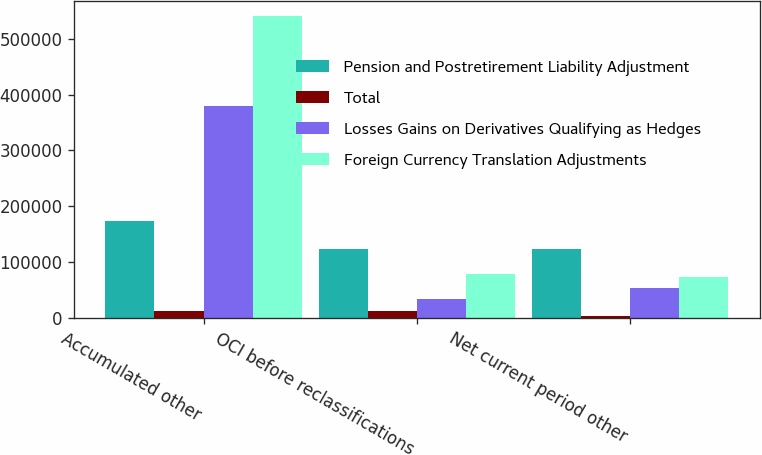<chart> <loc_0><loc_0><loc_500><loc_500><stacked_bar_chart><ecel><fcel>Accumulated other<fcel>OCI before reclassifications<fcel>Net current period other<nl><fcel>Pension and Postretirement Liability Adjustment<fcel>173342<fcel>124157<fcel>124157<nl><fcel>Total<fcel>12371<fcel>13006<fcel>2970<nl><fcel>Losses Gains on Derivatives Qualifying as Hedges<fcel>379459<fcel>33410<fcel>54117<nl><fcel>Foreign Currency Translation Adjustments<fcel>540430<fcel>77741<fcel>73010<nl></chart> 